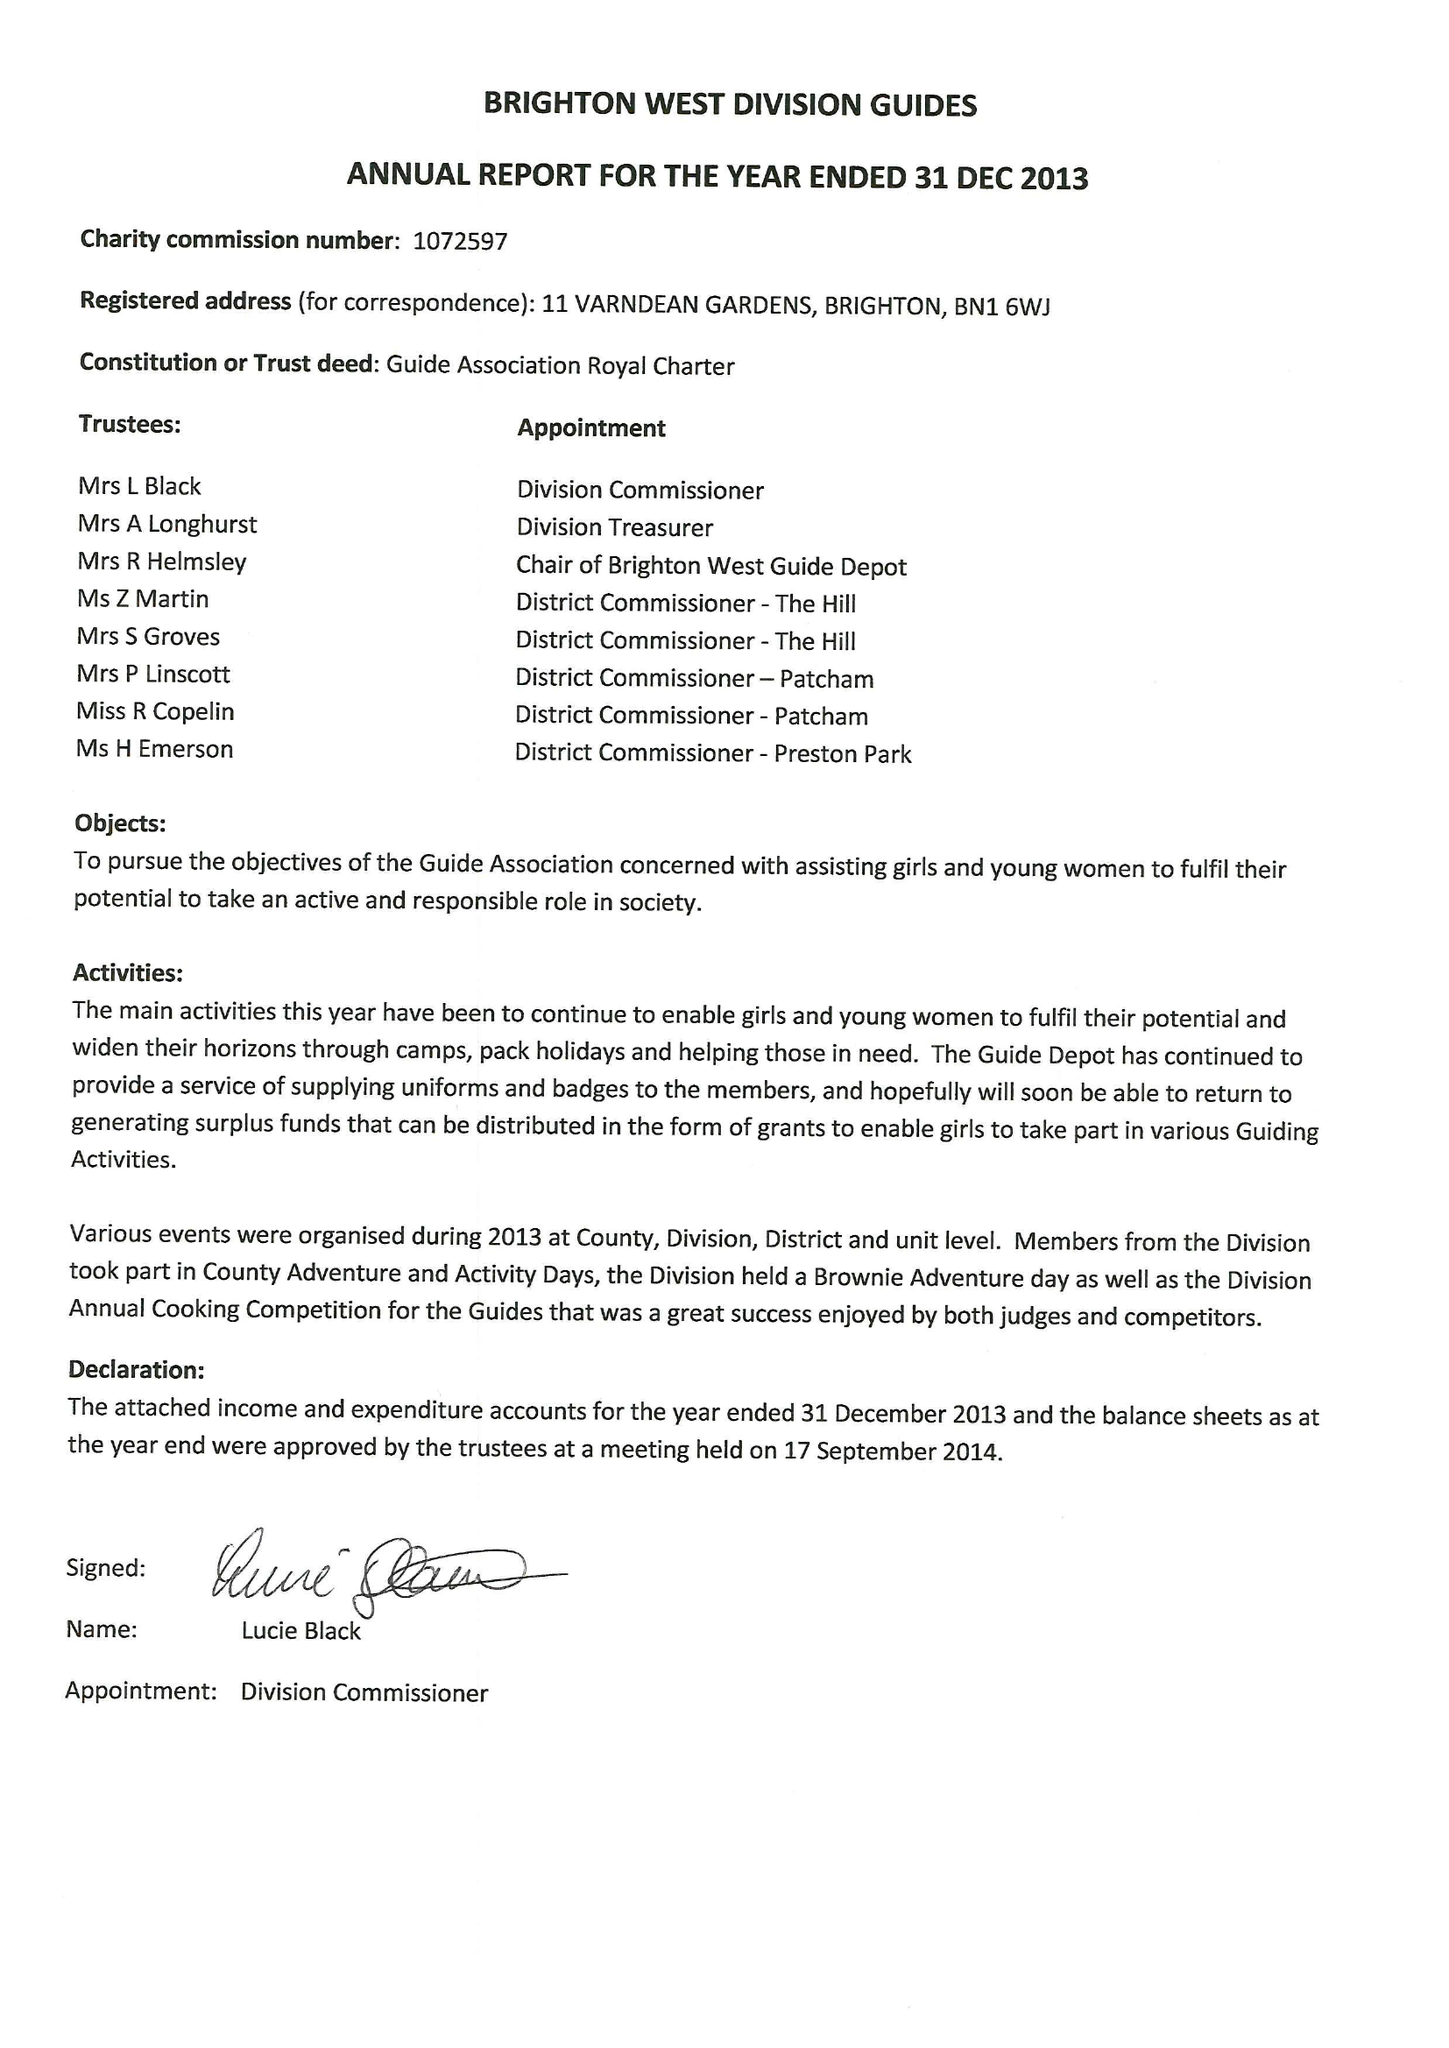What is the value for the charity_name?
Answer the question using a single word or phrase. Brighton West Division Guides 